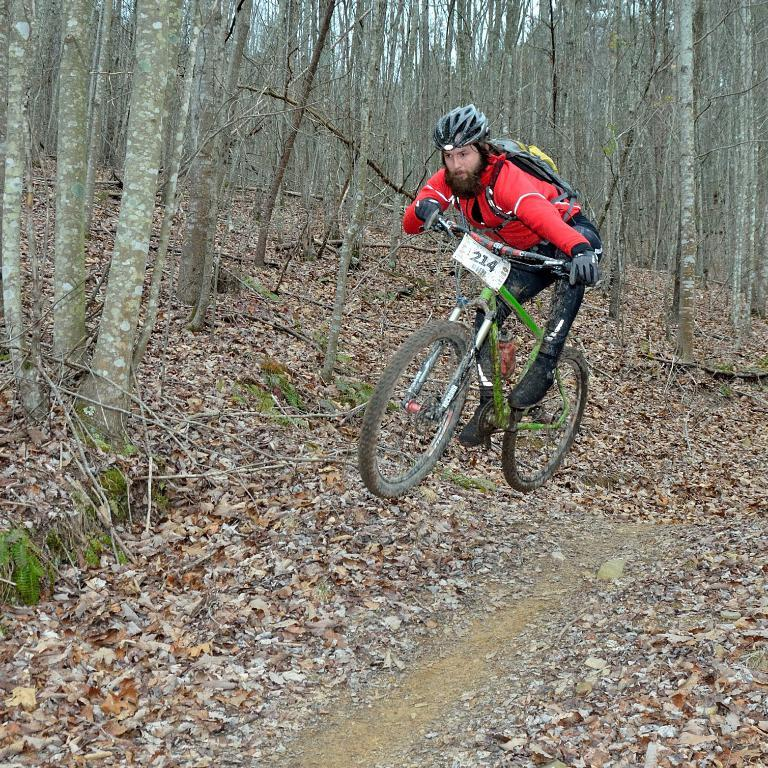What is the man in the image doing? The man is riding a bicycle in the image. What is the man wearing while riding the bicycle? The man is wearing a red coat and a black helmet. What can be seen in the background of the image? There are trees visible in the image. What is present at the bottom of the image? There are dried leaves at the bottom of the image. How many chickens can be seen in the image? There are no chickens present in the image. What is the man using to push the bicycle in the image? The man is not pushing the bicycle; he is riding it, so there is no need for a pushing mechanism. 